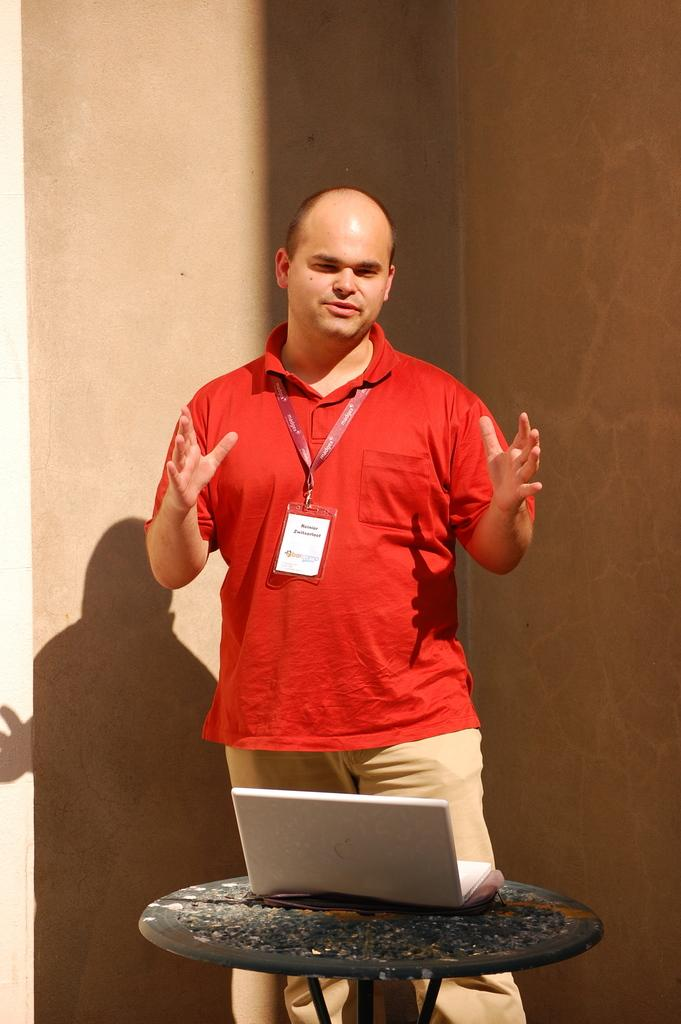What can be seen in the image? There is a person in the image. What is the person wearing? The person is wearing a red shirt and cream pants. What object is in front of the person? There is a laptop on a table in front of the person. What color is the background wall? The background wall is brown in color. What type of ornament is the person holding in the image? There is no ornament present in the image. How does the person's daughter feel about the laptop in the image? There is no mention of a daughter in the image, so we cannot determine her feelings about the laptop. 